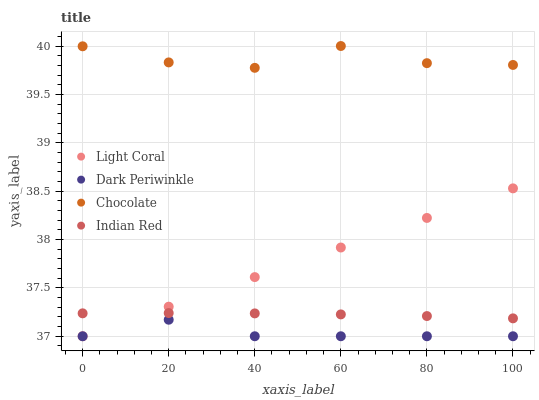Does Dark Periwinkle have the minimum area under the curve?
Answer yes or no. Yes. Does Chocolate have the maximum area under the curve?
Answer yes or no. Yes. Does Indian Red have the minimum area under the curve?
Answer yes or no. No. Does Indian Red have the maximum area under the curve?
Answer yes or no. No. Is Light Coral the smoothest?
Answer yes or no. Yes. Is Chocolate the roughest?
Answer yes or no. Yes. Is Dark Periwinkle the smoothest?
Answer yes or no. No. Is Dark Periwinkle the roughest?
Answer yes or no. No. Does Light Coral have the lowest value?
Answer yes or no. Yes. Does Indian Red have the lowest value?
Answer yes or no. No. Does Chocolate have the highest value?
Answer yes or no. Yes. Does Indian Red have the highest value?
Answer yes or no. No. Is Dark Periwinkle less than Chocolate?
Answer yes or no. Yes. Is Indian Red greater than Dark Periwinkle?
Answer yes or no. Yes. Does Indian Red intersect Light Coral?
Answer yes or no. Yes. Is Indian Red less than Light Coral?
Answer yes or no. No. Is Indian Red greater than Light Coral?
Answer yes or no. No. Does Dark Periwinkle intersect Chocolate?
Answer yes or no. No. 